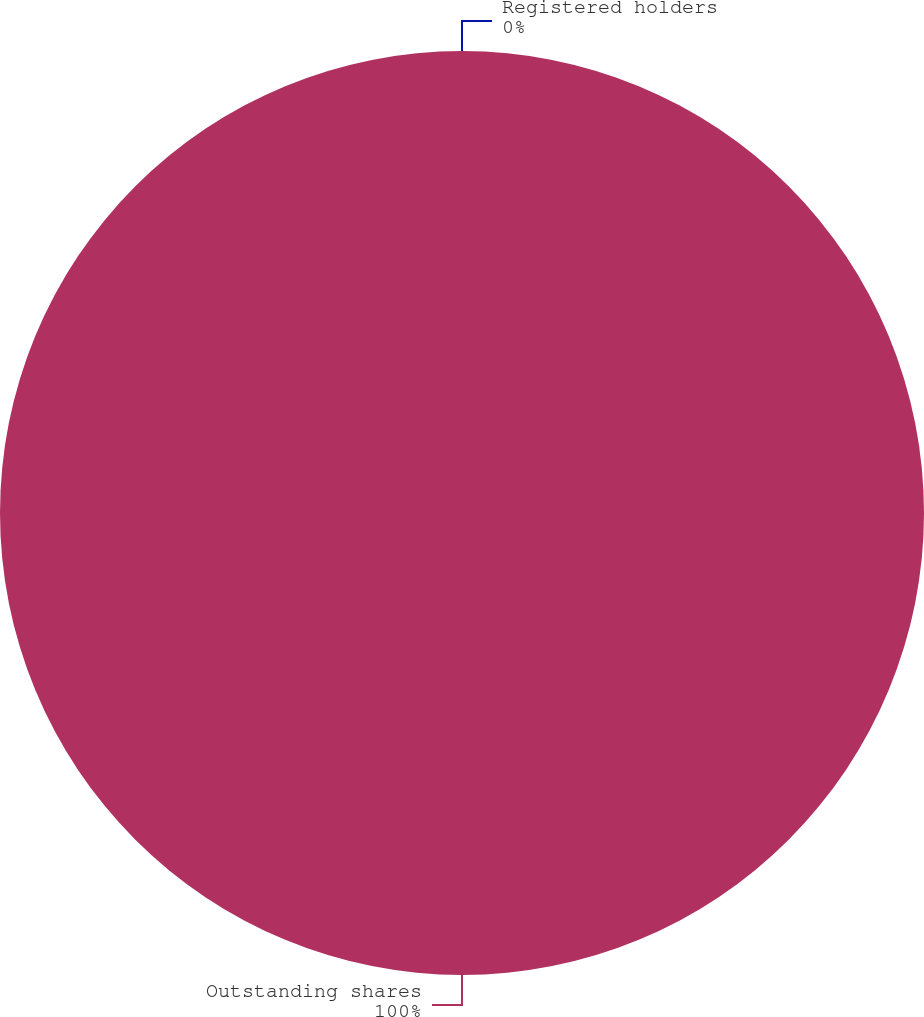<chart> <loc_0><loc_0><loc_500><loc_500><pie_chart><fcel>Outstanding shares<fcel>Registered holders<nl><fcel>100.0%<fcel>0.0%<nl></chart> 